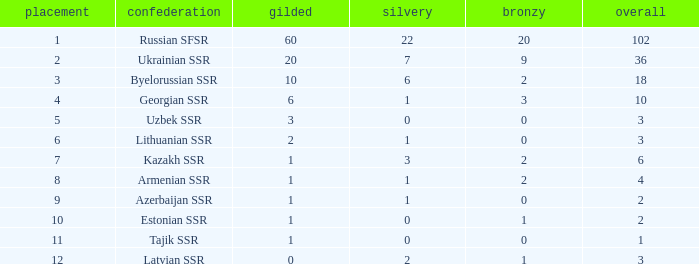What is the highest number of bronzes for teams ranked number 7 with more than 0 silver? 2.0. 